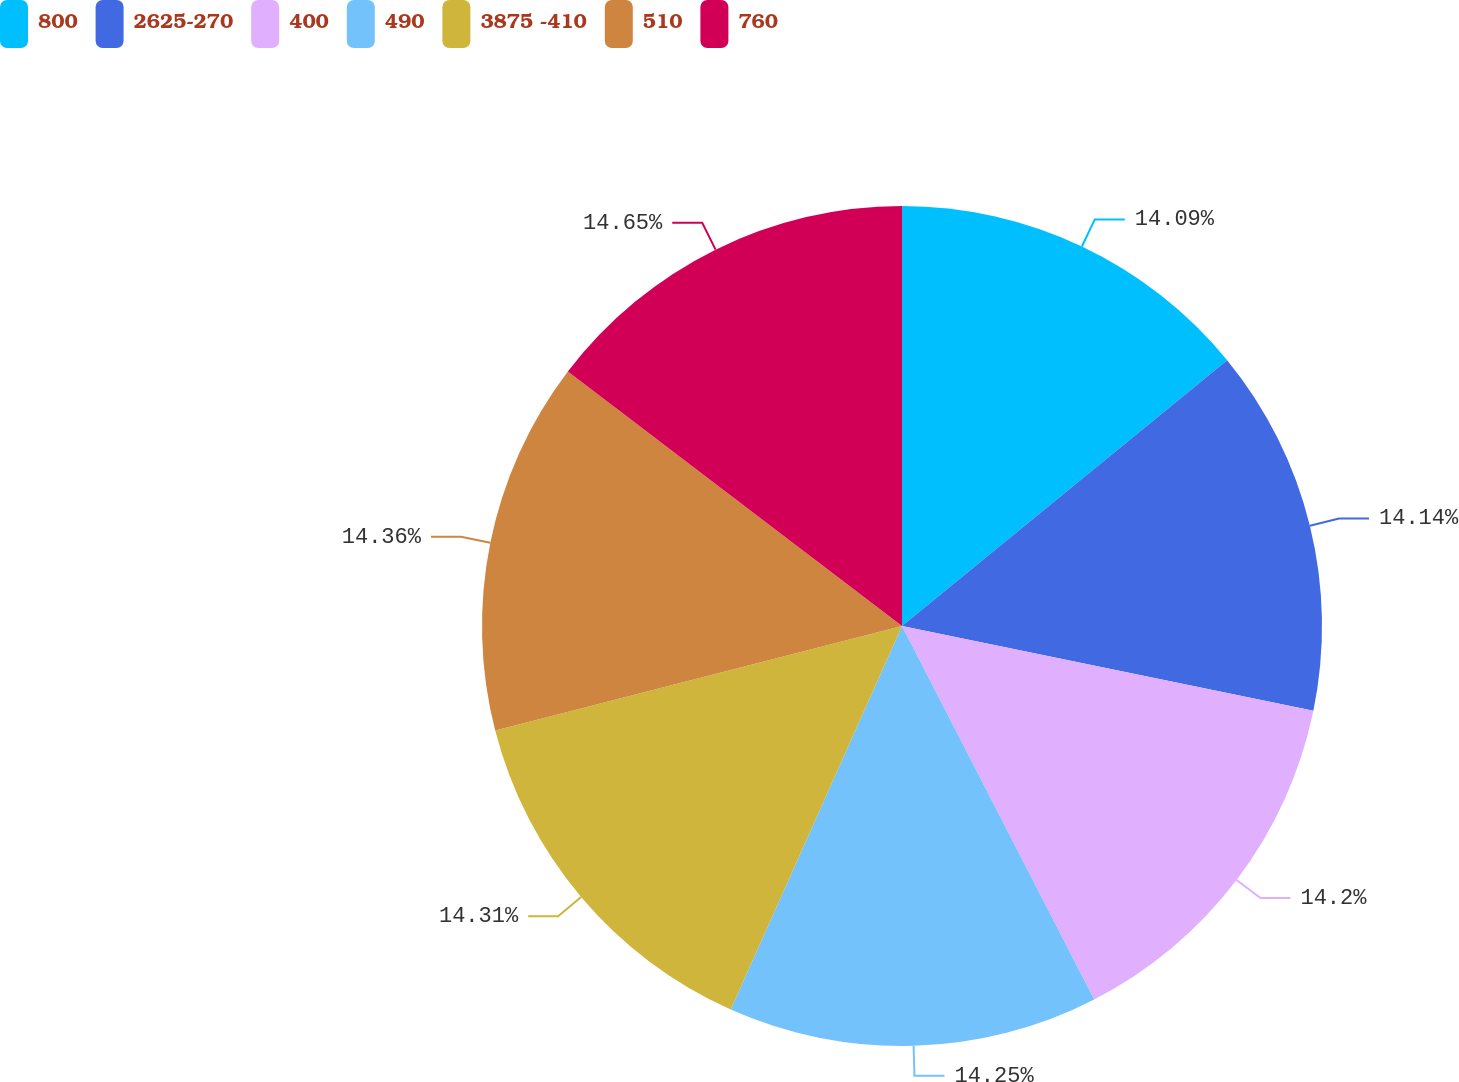<chart> <loc_0><loc_0><loc_500><loc_500><pie_chart><fcel>800<fcel>2625-270<fcel>400<fcel>490<fcel>3875 -410<fcel>510<fcel>760<nl><fcel>14.09%<fcel>14.14%<fcel>14.2%<fcel>14.25%<fcel>14.31%<fcel>14.36%<fcel>14.64%<nl></chart> 